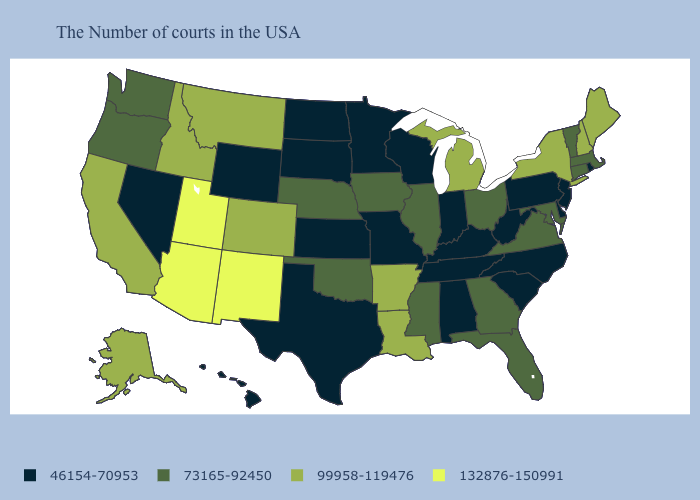What is the value of Vermont?
Give a very brief answer. 73165-92450. Does Utah have a higher value than New Mexico?
Write a very short answer. No. Which states have the highest value in the USA?
Answer briefly. New Mexico, Utah, Arizona. Among the states that border Illinois , which have the highest value?
Short answer required. Iowa. What is the value of Nebraska?
Write a very short answer. 73165-92450. What is the value of New Jersey?
Give a very brief answer. 46154-70953. Does Nebraska have the lowest value in the USA?
Write a very short answer. No. Among the states that border Wyoming , does Colorado have the highest value?
Short answer required. No. Among the states that border Illinois , which have the highest value?
Concise answer only. Iowa. What is the lowest value in the USA?
Quick response, please. 46154-70953. Does Missouri have the lowest value in the USA?
Short answer required. Yes. What is the value of Wyoming?
Quick response, please. 46154-70953. What is the lowest value in the MidWest?
Keep it brief. 46154-70953. Does South Dakota have the lowest value in the MidWest?
Short answer required. Yes. Which states have the lowest value in the South?
Concise answer only. Delaware, North Carolina, South Carolina, West Virginia, Kentucky, Alabama, Tennessee, Texas. 